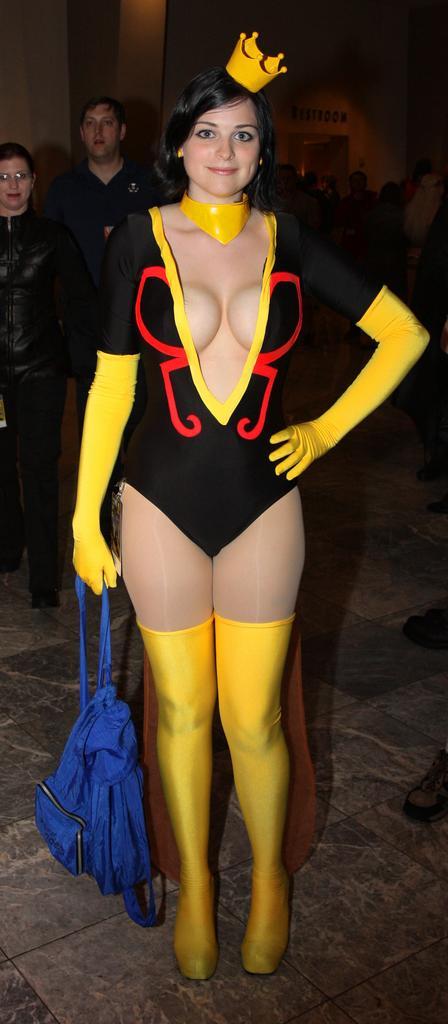Please provide a concise description of this image. In the foreground of the picture we can see a woman standing. On the left we can see two persons. In the background there are people and wall. 